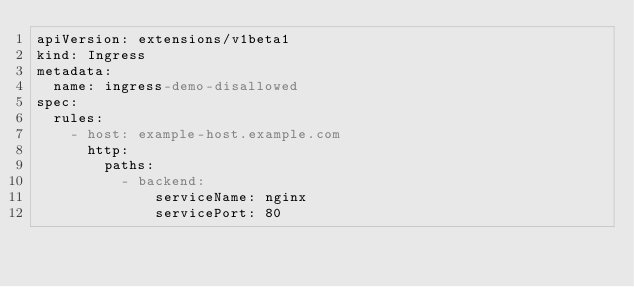<code> <loc_0><loc_0><loc_500><loc_500><_YAML_>apiVersion: extensions/v1beta1
kind: Ingress
metadata:
  name: ingress-demo-disallowed
spec:
  rules:
    - host: example-host.example.com
      http:
        paths:
          - backend:
              serviceName: nginx
              servicePort: 80
</code> 